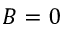<formula> <loc_0><loc_0><loc_500><loc_500>B = 0</formula> 